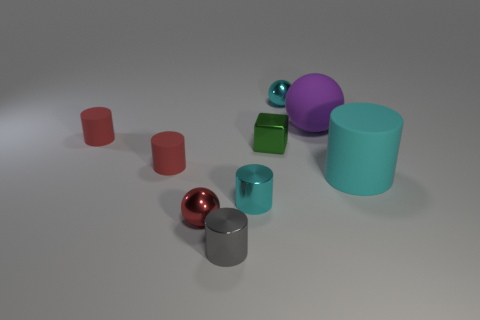There is a large ball; what number of small red cylinders are behind it?
Your response must be concise. 0. The red metallic thing that is the same shape as the purple rubber thing is what size?
Ensure brevity in your answer.  Small. What number of gray things are large things or large matte cylinders?
Ensure brevity in your answer.  0. There is a small cyan thing in front of the big sphere; what number of cyan matte cylinders are behind it?
Give a very brief answer. 1. What number of other things are there of the same shape as the tiny green shiny object?
Give a very brief answer. 0. There is a small sphere that is the same color as the large cylinder; what is its material?
Your answer should be very brief. Metal. What number of other cylinders have the same color as the big matte cylinder?
Provide a short and direct response. 1. There is a tiny cube that is the same material as the gray cylinder; what is its color?
Offer a very short reply. Green. Are there any gray matte cylinders that have the same size as the cyan rubber cylinder?
Offer a very short reply. No. Are there more small red spheres to the left of the tiny green object than purple rubber things to the right of the purple thing?
Keep it short and to the point. Yes. 